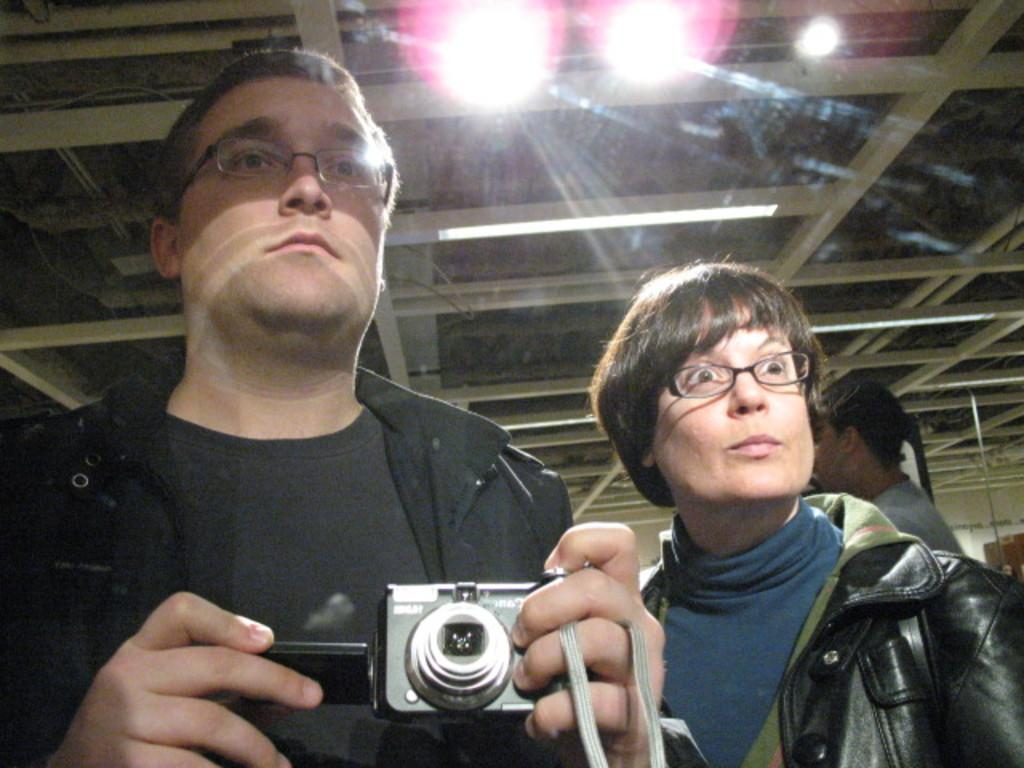What is the person in the image wearing? The person is wearing a black dress in the image. What is the person holding in his hand? The person is holding a camera in his hand. Can you describe the other person in the image? There is a lady standing beside the person. What type of destruction can be seen in the image? There is no destruction present in the image; it features a person wearing a black dress, holding a camera, and standing beside a lady. 